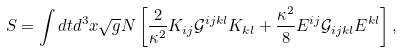<formula> <loc_0><loc_0><loc_500><loc_500>S = \int d t d ^ { 3 } x \sqrt { g } N \left [ \frac { 2 } { \kappa ^ { 2 } } K _ { i j } \mathcal { G } ^ { i j k l } K _ { k l } + \frac { \kappa ^ { 2 } } { 8 } E ^ { i j } \mathcal { G } _ { i j k l } E ^ { k l } \right ] ,</formula> 